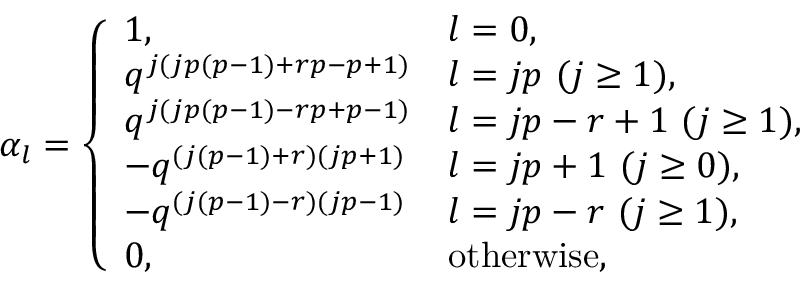<formula> <loc_0><loc_0><loc_500><loc_500>\alpha _ { l } = \left \{ \begin{array} { l l } { 1 , } & { l = 0 , } \\ { { q ^ { j ( j p ( p - 1 ) + r p - p + 1 ) } } } & { l = j p ( j \geq 1 ) , } \\ { { q ^ { j ( j p ( p - 1 ) - r p + p - 1 ) } } } & { l = j p - r + 1 ( j \geq 1 ) , } \\ { { - q ^ { ( j ( p - 1 ) + r ) ( j p + 1 ) } } } & { l = j p + 1 ( j \geq 0 ) , } \\ { { - q ^ { ( j ( p - 1 ) - r ) ( j p - 1 ) } } } & { l = j p - r ( j \geq 1 ) , } \\ { 0 , } & { o t h e r w i s e , } \end{array}</formula> 